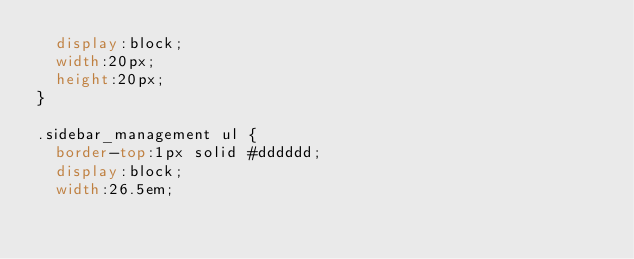<code> <loc_0><loc_0><loc_500><loc_500><_CSS_>	display:block;
	width:20px;
	height:20px;
}

.sidebar_management ul {
	border-top:1px solid #dddddd;
	display:block;
	width:26.5em;</code> 